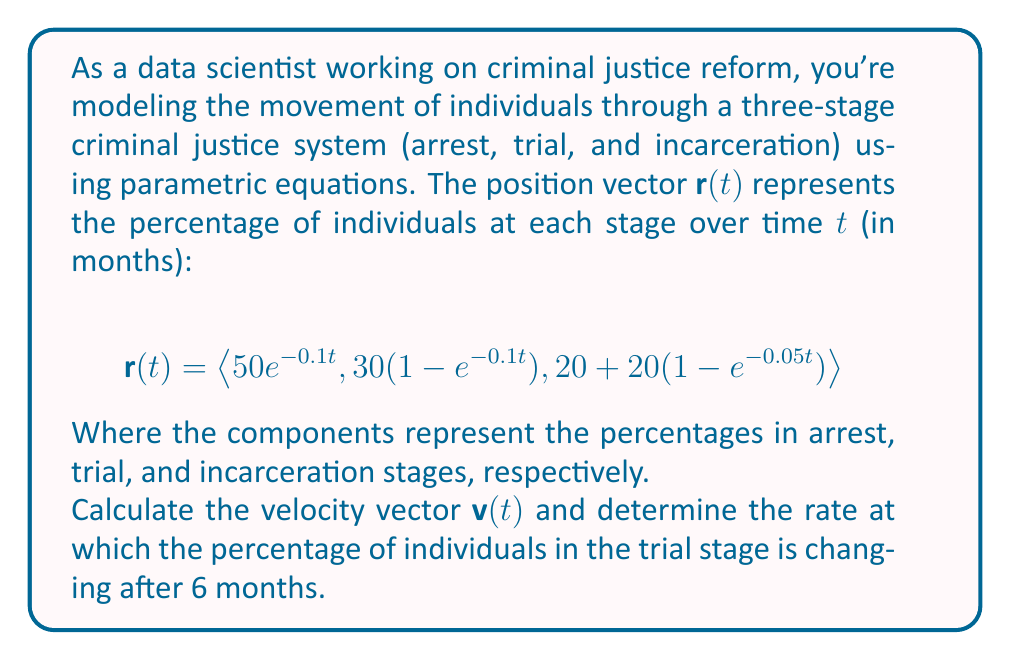Can you solve this math problem? To solve this problem, we'll follow these steps:

1) First, we need to find the velocity vector $\mathbf{v}(t)$ by differentiating $\mathbf{r}(t)$ with respect to $t$:

   $$\mathbf{v}(t) = \frac{d}{dt}\mathbf{r}(t) = \left\langle \frac{d}{dt}(50e^{-0.1t}), \frac{d}{dt}(30(1-e^{-0.1t})), \frac{d}{dt}(20+20(1-e^{-0.05t})) \right\rangle$$

2) Let's differentiate each component:

   - For the first component: $\frac{d}{dt}(50e^{-0.1t}) = -5e^{-0.1t}$
   - For the second component: $\frac{d}{dt}(30(1-e^{-0.1t})) = 3e^{-0.1t}$
   - For the third component: $\frac{d}{dt}(20+20(1-e^{-0.05t})) = e^{-0.05t}$

3) Thus, the velocity vector is:

   $$\mathbf{v}(t) = \left\langle -5e^{-0.1t}, 3e^{-0.1t}, e^{-0.05t} \right\rangle$$

4) The question asks for the rate of change in the trial stage after 6 months. This corresponds to the second component of $\mathbf{v}(t)$ at $t=6$:

   Rate of change in trial stage = $3e^{-0.1(6)} = 3e^{-0.6}$

5) Calculate this value:

   $3e^{-0.6} \approx 1.648$ (rounded to three decimal places)

This result represents the rate of change (in percentage points per month) of individuals in the trial stage after 6 months.
Answer: $1.648\%$ per month 